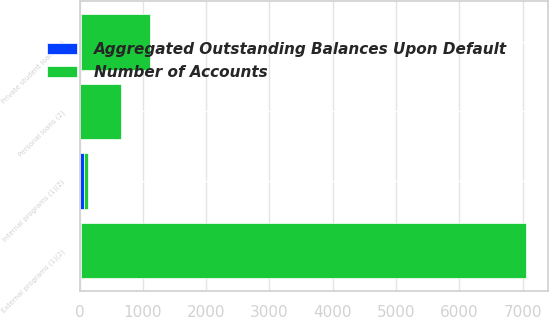Convert chart to OTSL. <chart><loc_0><loc_0><loc_500><loc_500><stacked_bar_chart><ecel><fcel>Internal programs (1)(2)<fcel>External programs (1)(2)<fcel>Personal loans (2)<fcel>Private student loans (3)<nl><fcel>Number of Accounts<fcel>69<fcel>7026<fcel>644<fcel>1103<nl><fcel>Aggregated Outstanding Balances Upon Default<fcel>69<fcel>27<fcel>7<fcel>16<nl></chart> 